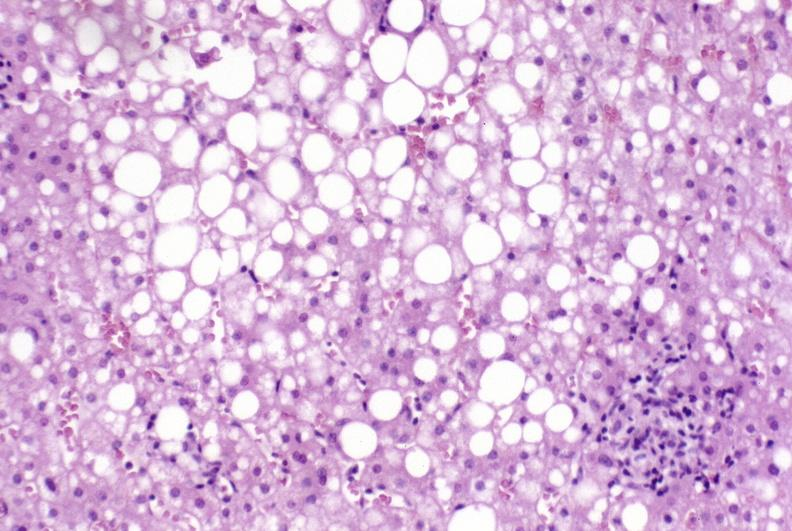what does this image show?
Answer the question using a single word or phrase. Primary biliary cirrhosis 